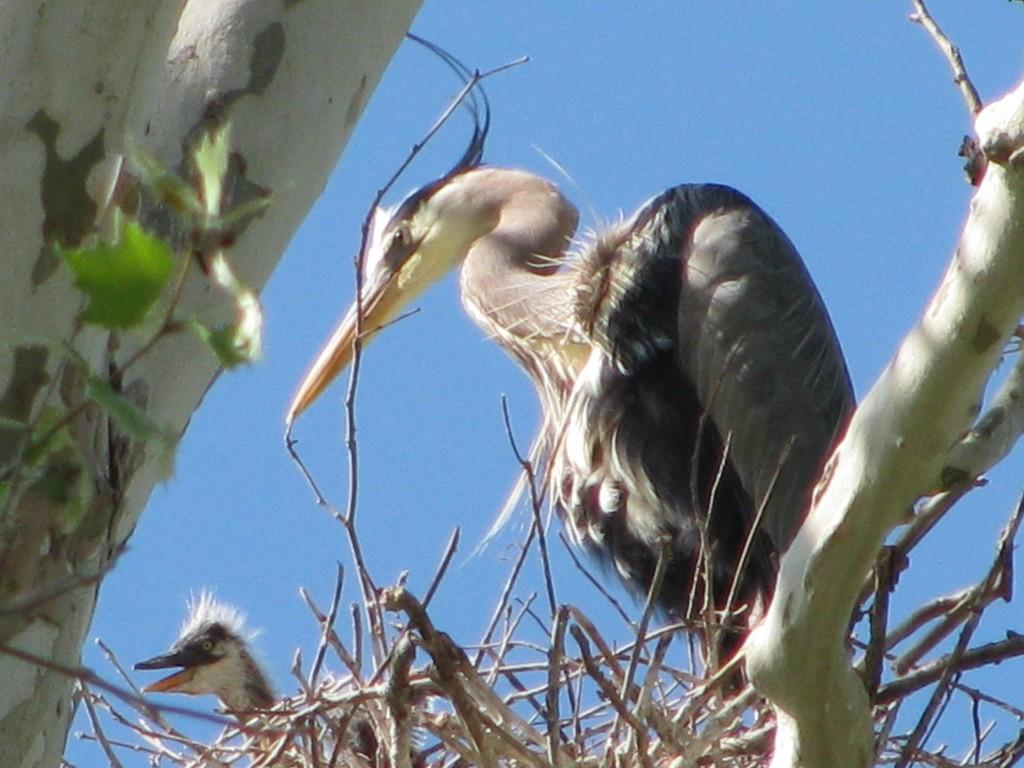How many birds are in the image? There are two birds in the image. Where are the birds located? The birds are standing on a branch of a tree. What else can be seen on the tree in the image? There is a nest on the tree. What is visible at the top of the image? The sky is visible at the top of the image. What type of face can be seen on the bird in the image? There are no faces visible on the birds in the image, as they are birds and do not have human-like facial features. 